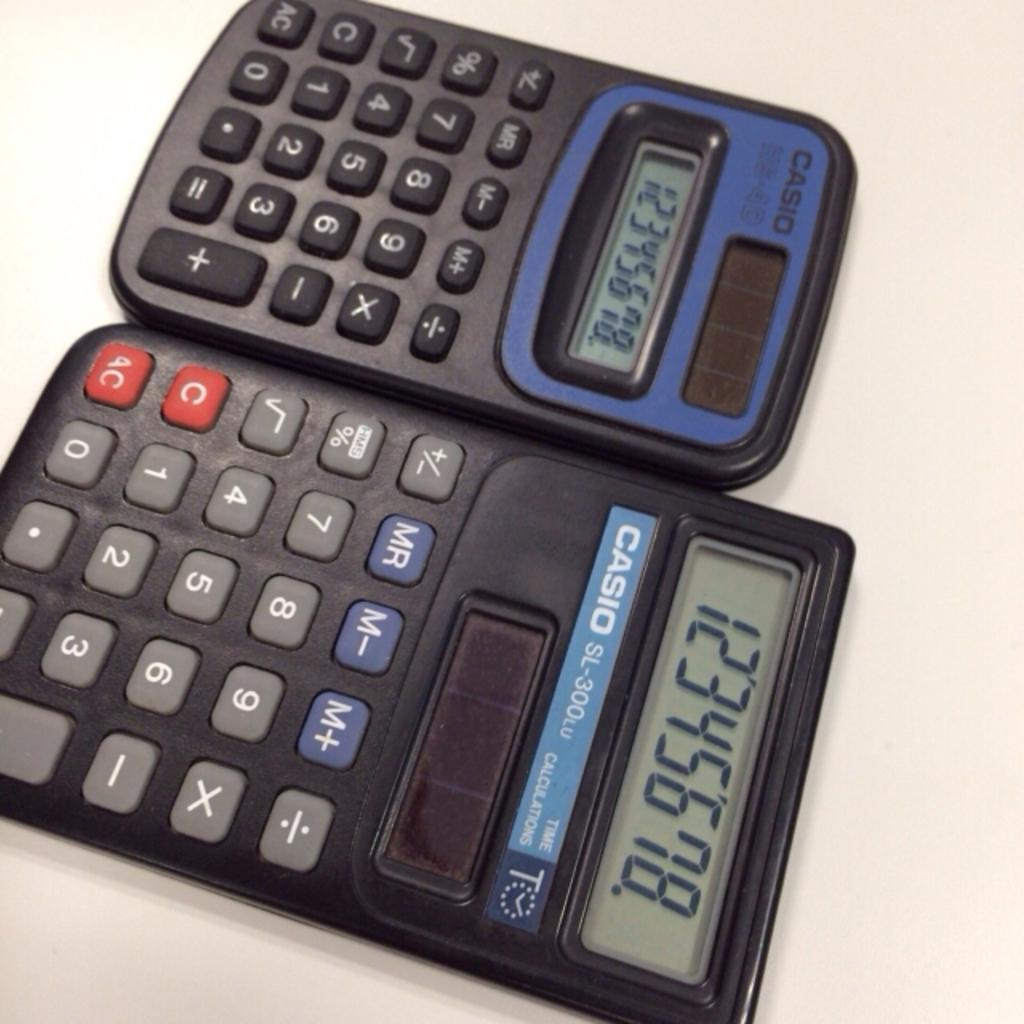What are the numbers across the larger calculator's screen?
Your answer should be compact. 12345678. What brand are these calculators?
Your answer should be compact. Casio. 